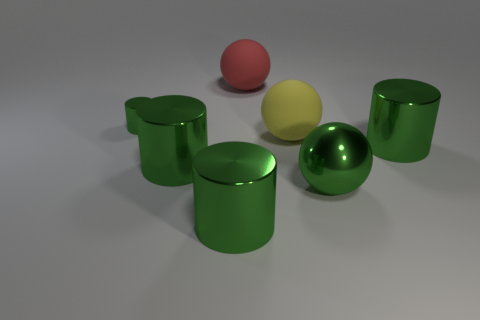Is the large object that is behind the yellow ball made of the same material as the green cylinder that is on the right side of the red sphere?
Provide a short and direct response. No. What is the material of the tiny object?
Ensure brevity in your answer.  Metal. Is the number of big metallic cylinders that are in front of the large yellow sphere greater than the number of green balls?
Your response must be concise. Yes. How many big cylinders are in front of the green object that is behind the thing that is to the right of the metallic ball?
Your response must be concise. 3. The object that is both to the left of the big red thing and behind the big yellow thing is made of what material?
Your answer should be very brief. Metal. The big metallic sphere is what color?
Your response must be concise. Green. Are there more green cylinders right of the tiny green cylinder than shiny cylinders in front of the metal ball?
Keep it short and to the point. Yes. The big rubber object that is behind the tiny metallic thing is what color?
Provide a short and direct response. Red. There is a green shiny cylinder that is behind the large yellow matte sphere; does it have the same size as the rubber thing that is behind the small green cylinder?
Provide a succinct answer. No. How many things are large green metal cylinders or red spheres?
Ensure brevity in your answer.  4. 